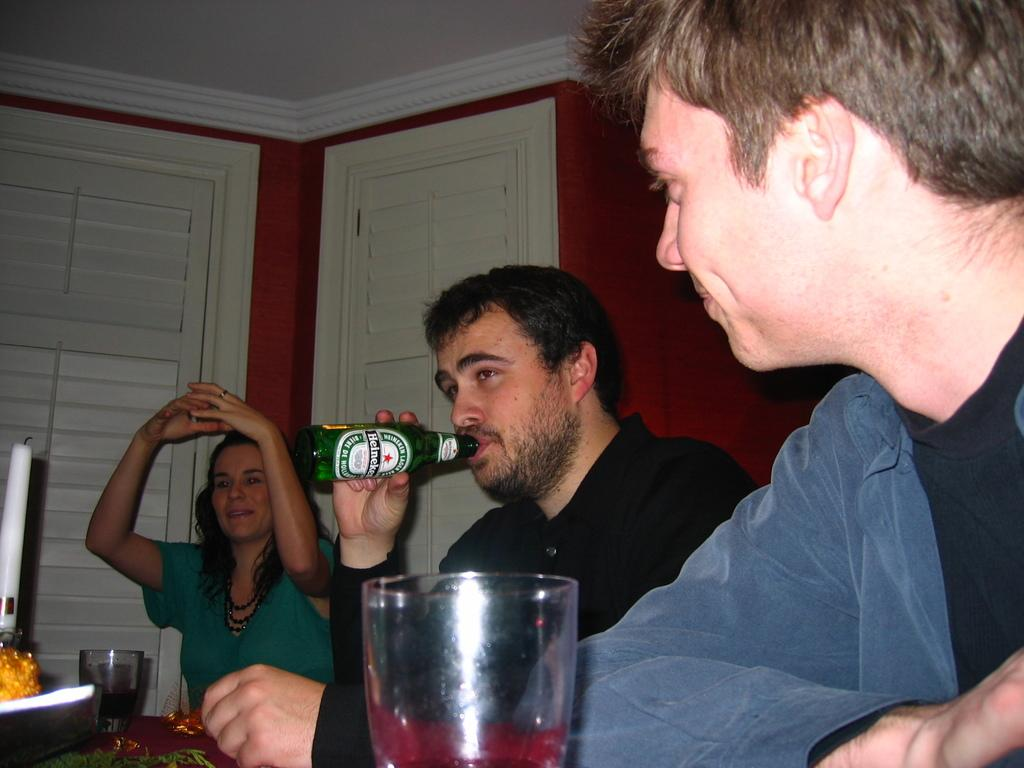How many people are in the image? There are three people in the image: two men and a woman. What is one of the men holding in the image? One of the men is holding a bottle in the image. What objects are on the table in the image? There are two glasses and a candle on the table in the image. Are the two men in the image engaged in a fight? No, there is no indication of a fight in the image; the two men are simply standing together. What is used to light the candle in the image? There is no match or any other object used to light the candle visible in the image. 